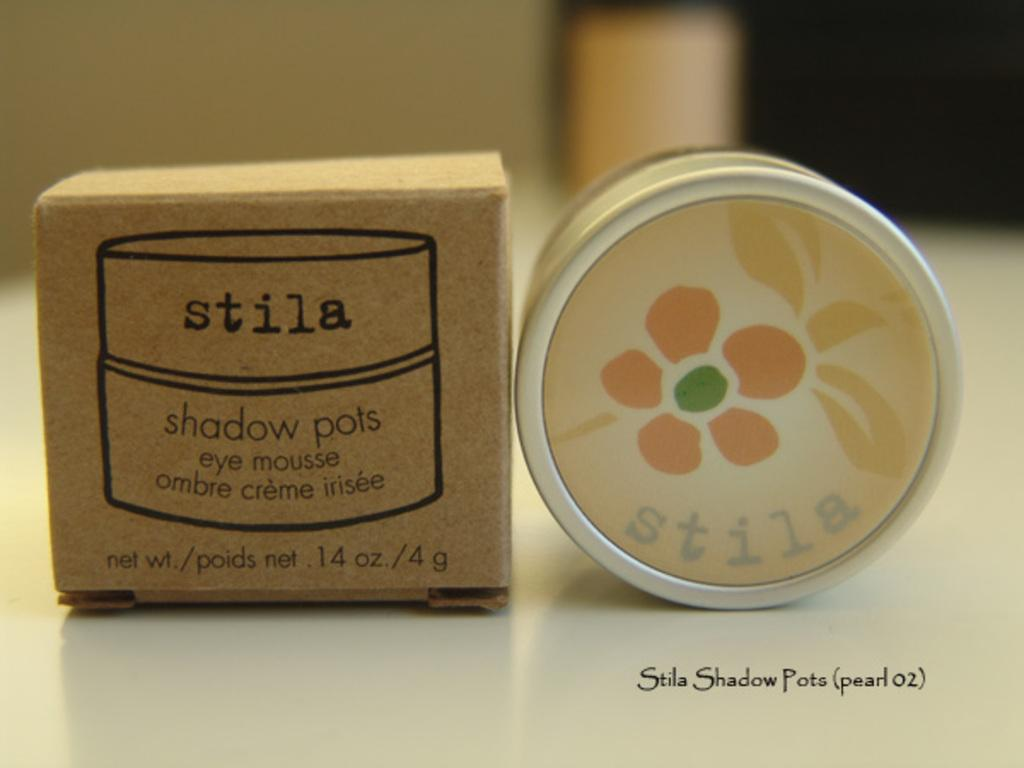<image>
Provide a brief description of the given image. a can of stila eye mousse called shadow pots 